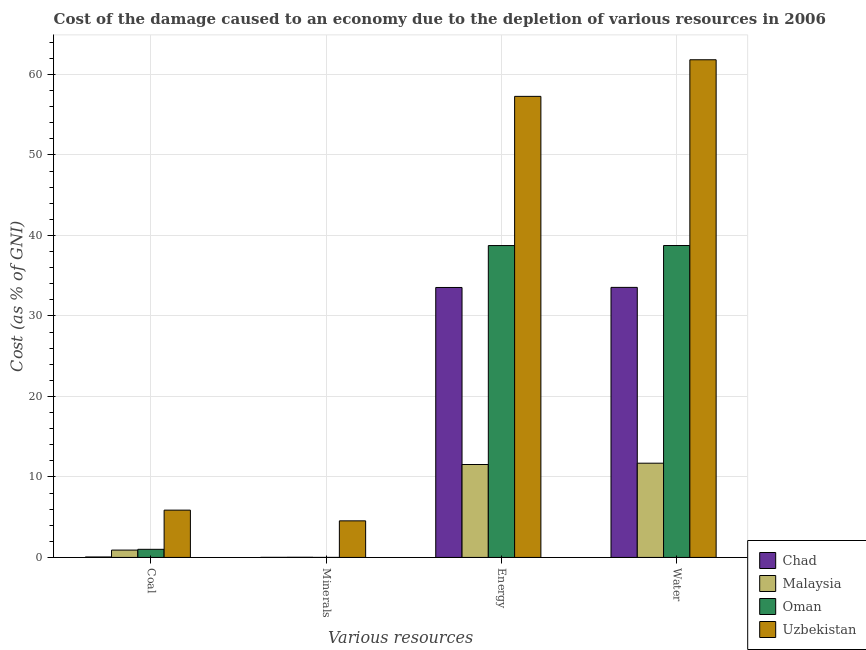Are the number of bars per tick equal to the number of legend labels?
Provide a succinct answer. Yes. Are the number of bars on each tick of the X-axis equal?
Ensure brevity in your answer.  Yes. How many bars are there on the 2nd tick from the left?
Your response must be concise. 4. How many bars are there on the 2nd tick from the right?
Offer a very short reply. 4. What is the label of the 4th group of bars from the left?
Make the answer very short. Water. What is the cost of damage due to depletion of energy in Chad?
Offer a terse response. 33.53. Across all countries, what is the maximum cost of damage due to depletion of energy?
Ensure brevity in your answer.  57.27. Across all countries, what is the minimum cost of damage due to depletion of minerals?
Your answer should be very brief. 0. In which country was the cost of damage due to depletion of coal maximum?
Offer a very short reply. Uzbekistan. In which country was the cost of damage due to depletion of water minimum?
Make the answer very short. Malaysia. What is the total cost of damage due to depletion of minerals in the graph?
Give a very brief answer. 4.58. What is the difference between the cost of damage due to depletion of minerals in Uzbekistan and that in Chad?
Your response must be concise. 4.53. What is the difference between the cost of damage due to depletion of coal in Uzbekistan and the cost of damage due to depletion of energy in Malaysia?
Keep it short and to the point. -5.67. What is the average cost of damage due to depletion of water per country?
Provide a succinct answer. 36.45. What is the difference between the cost of damage due to depletion of energy and cost of damage due to depletion of water in Malaysia?
Your response must be concise. -0.16. What is the ratio of the cost of damage due to depletion of minerals in Chad to that in Malaysia?
Offer a very short reply. 0.52. What is the difference between the highest and the second highest cost of damage due to depletion of minerals?
Your answer should be very brief. 4.52. What is the difference between the highest and the lowest cost of damage due to depletion of energy?
Ensure brevity in your answer.  45.73. In how many countries, is the cost of damage due to depletion of minerals greater than the average cost of damage due to depletion of minerals taken over all countries?
Give a very brief answer. 1. Is the sum of the cost of damage due to depletion of coal in Oman and Malaysia greater than the maximum cost of damage due to depletion of energy across all countries?
Ensure brevity in your answer.  No. What does the 1st bar from the left in Minerals represents?
Provide a short and direct response. Chad. What does the 2nd bar from the right in Coal represents?
Provide a short and direct response. Oman. Is it the case that in every country, the sum of the cost of damage due to depletion of coal and cost of damage due to depletion of minerals is greater than the cost of damage due to depletion of energy?
Give a very brief answer. No. How many bars are there?
Offer a very short reply. 16. Does the graph contain any zero values?
Make the answer very short. No. Where does the legend appear in the graph?
Make the answer very short. Bottom right. How are the legend labels stacked?
Ensure brevity in your answer.  Vertical. What is the title of the graph?
Your answer should be very brief. Cost of the damage caused to an economy due to the depletion of various resources in 2006 . Does "Latvia" appear as one of the legend labels in the graph?
Your answer should be very brief. No. What is the label or title of the X-axis?
Provide a short and direct response. Various resources. What is the label or title of the Y-axis?
Your answer should be compact. Cost (as % of GNI). What is the Cost (as % of GNI) of Chad in Coal?
Provide a succinct answer. 0.06. What is the Cost (as % of GNI) in Malaysia in Coal?
Your answer should be compact. 0.91. What is the Cost (as % of GNI) of Oman in Coal?
Your answer should be very brief. 1.01. What is the Cost (as % of GNI) of Uzbekistan in Coal?
Your response must be concise. 5.88. What is the Cost (as % of GNI) of Chad in Minerals?
Give a very brief answer. 0.01. What is the Cost (as % of GNI) of Malaysia in Minerals?
Your answer should be compact. 0.02. What is the Cost (as % of GNI) in Oman in Minerals?
Provide a succinct answer. 0. What is the Cost (as % of GNI) of Uzbekistan in Minerals?
Keep it short and to the point. 4.54. What is the Cost (as % of GNI) of Chad in Energy?
Your response must be concise. 33.53. What is the Cost (as % of GNI) of Malaysia in Energy?
Your answer should be very brief. 11.54. What is the Cost (as % of GNI) of Oman in Energy?
Give a very brief answer. 38.74. What is the Cost (as % of GNI) in Uzbekistan in Energy?
Offer a terse response. 57.27. What is the Cost (as % of GNI) of Chad in Water?
Give a very brief answer. 33.54. What is the Cost (as % of GNI) in Malaysia in Water?
Offer a very short reply. 11.71. What is the Cost (as % of GNI) in Oman in Water?
Your response must be concise. 38.75. What is the Cost (as % of GNI) of Uzbekistan in Water?
Give a very brief answer. 61.82. Across all Various resources, what is the maximum Cost (as % of GNI) in Chad?
Provide a short and direct response. 33.54. Across all Various resources, what is the maximum Cost (as % of GNI) of Malaysia?
Keep it short and to the point. 11.71. Across all Various resources, what is the maximum Cost (as % of GNI) in Oman?
Keep it short and to the point. 38.75. Across all Various resources, what is the maximum Cost (as % of GNI) of Uzbekistan?
Your answer should be compact. 61.82. Across all Various resources, what is the minimum Cost (as % of GNI) of Chad?
Make the answer very short. 0.01. Across all Various resources, what is the minimum Cost (as % of GNI) in Malaysia?
Your answer should be very brief. 0.02. Across all Various resources, what is the minimum Cost (as % of GNI) in Oman?
Keep it short and to the point. 0. Across all Various resources, what is the minimum Cost (as % of GNI) of Uzbekistan?
Your answer should be very brief. 4.54. What is the total Cost (as % of GNI) in Chad in the graph?
Provide a short and direct response. 67.15. What is the total Cost (as % of GNI) of Malaysia in the graph?
Offer a very short reply. 24.18. What is the total Cost (as % of GNI) of Oman in the graph?
Provide a succinct answer. 78.5. What is the total Cost (as % of GNI) in Uzbekistan in the graph?
Ensure brevity in your answer.  129.52. What is the difference between the Cost (as % of GNI) of Chad in Coal and that in Minerals?
Offer a terse response. 0.05. What is the difference between the Cost (as % of GNI) of Malaysia in Coal and that in Minerals?
Provide a succinct answer. 0.89. What is the difference between the Cost (as % of GNI) in Oman in Coal and that in Minerals?
Provide a short and direct response. 1. What is the difference between the Cost (as % of GNI) in Uzbekistan in Coal and that in Minerals?
Make the answer very short. 1.33. What is the difference between the Cost (as % of GNI) in Chad in Coal and that in Energy?
Offer a very short reply. -33.48. What is the difference between the Cost (as % of GNI) in Malaysia in Coal and that in Energy?
Provide a short and direct response. -10.63. What is the difference between the Cost (as % of GNI) of Oman in Coal and that in Energy?
Your answer should be compact. -37.73. What is the difference between the Cost (as % of GNI) in Uzbekistan in Coal and that in Energy?
Ensure brevity in your answer.  -51.4. What is the difference between the Cost (as % of GNI) of Chad in Coal and that in Water?
Offer a terse response. -33.49. What is the difference between the Cost (as % of GNI) of Malaysia in Coal and that in Water?
Make the answer very short. -10.79. What is the difference between the Cost (as % of GNI) of Oman in Coal and that in Water?
Your answer should be compact. -37.74. What is the difference between the Cost (as % of GNI) of Uzbekistan in Coal and that in Water?
Your response must be concise. -55.95. What is the difference between the Cost (as % of GNI) in Chad in Minerals and that in Energy?
Your response must be concise. -33.52. What is the difference between the Cost (as % of GNI) of Malaysia in Minerals and that in Energy?
Offer a very short reply. -11.52. What is the difference between the Cost (as % of GNI) of Oman in Minerals and that in Energy?
Offer a terse response. -38.74. What is the difference between the Cost (as % of GNI) in Uzbekistan in Minerals and that in Energy?
Your answer should be compact. -52.73. What is the difference between the Cost (as % of GNI) of Chad in Minerals and that in Water?
Provide a short and direct response. -33.53. What is the difference between the Cost (as % of GNI) of Malaysia in Minerals and that in Water?
Provide a short and direct response. -11.69. What is the difference between the Cost (as % of GNI) in Oman in Minerals and that in Water?
Your response must be concise. -38.74. What is the difference between the Cost (as % of GNI) in Uzbekistan in Minerals and that in Water?
Provide a succinct answer. -57.28. What is the difference between the Cost (as % of GNI) of Chad in Energy and that in Water?
Ensure brevity in your answer.  -0.01. What is the difference between the Cost (as % of GNI) in Malaysia in Energy and that in Water?
Your answer should be very brief. -0.16. What is the difference between the Cost (as % of GNI) in Oman in Energy and that in Water?
Keep it short and to the point. -0.01. What is the difference between the Cost (as % of GNI) in Uzbekistan in Energy and that in Water?
Offer a very short reply. -4.55. What is the difference between the Cost (as % of GNI) of Chad in Coal and the Cost (as % of GNI) of Malaysia in Minerals?
Provide a succinct answer. 0.04. What is the difference between the Cost (as % of GNI) in Chad in Coal and the Cost (as % of GNI) in Oman in Minerals?
Provide a succinct answer. 0.05. What is the difference between the Cost (as % of GNI) of Chad in Coal and the Cost (as % of GNI) of Uzbekistan in Minerals?
Provide a succinct answer. -4.49. What is the difference between the Cost (as % of GNI) in Malaysia in Coal and the Cost (as % of GNI) in Oman in Minerals?
Provide a succinct answer. 0.91. What is the difference between the Cost (as % of GNI) in Malaysia in Coal and the Cost (as % of GNI) in Uzbekistan in Minerals?
Your answer should be very brief. -3.63. What is the difference between the Cost (as % of GNI) of Oman in Coal and the Cost (as % of GNI) of Uzbekistan in Minerals?
Keep it short and to the point. -3.54. What is the difference between the Cost (as % of GNI) in Chad in Coal and the Cost (as % of GNI) in Malaysia in Energy?
Offer a terse response. -11.49. What is the difference between the Cost (as % of GNI) of Chad in Coal and the Cost (as % of GNI) of Oman in Energy?
Give a very brief answer. -38.69. What is the difference between the Cost (as % of GNI) in Chad in Coal and the Cost (as % of GNI) in Uzbekistan in Energy?
Your answer should be compact. -57.22. What is the difference between the Cost (as % of GNI) in Malaysia in Coal and the Cost (as % of GNI) in Oman in Energy?
Offer a very short reply. -37.83. What is the difference between the Cost (as % of GNI) of Malaysia in Coal and the Cost (as % of GNI) of Uzbekistan in Energy?
Make the answer very short. -56.36. What is the difference between the Cost (as % of GNI) of Oman in Coal and the Cost (as % of GNI) of Uzbekistan in Energy?
Offer a very short reply. -56.27. What is the difference between the Cost (as % of GNI) in Chad in Coal and the Cost (as % of GNI) in Malaysia in Water?
Ensure brevity in your answer.  -11.65. What is the difference between the Cost (as % of GNI) of Chad in Coal and the Cost (as % of GNI) of Oman in Water?
Offer a terse response. -38.69. What is the difference between the Cost (as % of GNI) of Chad in Coal and the Cost (as % of GNI) of Uzbekistan in Water?
Give a very brief answer. -61.77. What is the difference between the Cost (as % of GNI) in Malaysia in Coal and the Cost (as % of GNI) in Oman in Water?
Keep it short and to the point. -37.83. What is the difference between the Cost (as % of GNI) of Malaysia in Coal and the Cost (as % of GNI) of Uzbekistan in Water?
Provide a succinct answer. -60.91. What is the difference between the Cost (as % of GNI) of Oman in Coal and the Cost (as % of GNI) of Uzbekistan in Water?
Your answer should be very brief. -60.82. What is the difference between the Cost (as % of GNI) of Chad in Minerals and the Cost (as % of GNI) of Malaysia in Energy?
Give a very brief answer. -11.53. What is the difference between the Cost (as % of GNI) of Chad in Minerals and the Cost (as % of GNI) of Oman in Energy?
Your response must be concise. -38.73. What is the difference between the Cost (as % of GNI) in Chad in Minerals and the Cost (as % of GNI) in Uzbekistan in Energy?
Give a very brief answer. -57.26. What is the difference between the Cost (as % of GNI) in Malaysia in Minerals and the Cost (as % of GNI) in Oman in Energy?
Offer a very short reply. -38.72. What is the difference between the Cost (as % of GNI) of Malaysia in Minerals and the Cost (as % of GNI) of Uzbekistan in Energy?
Provide a short and direct response. -57.25. What is the difference between the Cost (as % of GNI) in Oman in Minerals and the Cost (as % of GNI) in Uzbekistan in Energy?
Your response must be concise. -57.27. What is the difference between the Cost (as % of GNI) of Chad in Minerals and the Cost (as % of GNI) of Malaysia in Water?
Make the answer very short. -11.7. What is the difference between the Cost (as % of GNI) of Chad in Minerals and the Cost (as % of GNI) of Oman in Water?
Your response must be concise. -38.74. What is the difference between the Cost (as % of GNI) of Chad in Minerals and the Cost (as % of GNI) of Uzbekistan in Water?
Provide a short and direct response. -61.81. What is the difference between the Cost (as % of GNI) of Malaysia in Minerals and the Cost (as % of GNI) of Oman in Water?
Provide a succinct answer. -38.73. What is the difference between the Cost (as % of GNI) of Malaysia in Minerals and the Cost (as % of GNI) of Uzbekistan in Water?
Your answer should be very brief. -61.8. What is the difference between the Cost (as % of GNI) in Oman in Minerals and the Cost (as % of GNI) in Uzbekistan in Water?
Make the answer very short. -61.82. What is the difference between the Cost (as % of GNI) of Chad in Energy and the Cost (as % of GNI) of Malaysia in Water?
Offer a very short reply. 21.83. What is the difference between the Cost (as % of GNI) in Chad in Energy and the Cost (as % of GNI) in Oman in Water?
Provide a succinct answer. -5.21. What is the difference between the Cost (as % of GNI) in Chad in Energy and the Cost (as % of GNI) in Uzbekistan in Water?
Your answer should be compact. -28.29. What is the difference between the Cost (as % of GNI) of Malaysia in Energy and the Cost (as % of GNI) of Oman in Water?
Keep it short and to the point. -27.2. What is the difference between the Cost (as % of GNI) in Malaysia in Energy and the Cost (as % of GNI) in Uzbekistan in Water?
Offer a terse response. -50.28. What is the difference between the Cost (as % of GNI) in Oman in Energy and the Cost (as % of GNI) in Uzbekistan in Water?
Offer a terse response. -23.08. What is the average Cost (as % of GNI) of Chad per Various resources?
Offer a very short reply. 16.79. What is the average Cost (as % of GNI) of Malaysia per Various resources?
Make the answer very short. 6.05. What is the average Cost (as % of GNI) of Oman per Various resources?
Provide a succinct answer. 19.62. What is the average Cost (as % of GNI) in Uzbekistan per Various resources?
Your answer should be very brief. 32.38. What is the difference between the Cost (as % of GNI) in Chad and Cost (as % of GNI) in Malaysia in Coal?
Your answer should be compact. -0.86. What is the difference between the Cost (as % of GNI) of Chad and Cost (as % of GNI) of Oman in Coal?
Offer a very short reply. -0.95. What is the difference between the Cost (as % of GNI) in Chad and Cost (as % of GNI) in Uzbekistan in Coal?
Keep it short and to the point. -5.82. What is the difference between the Cost (as % of GNI) of Malaysia and Cost (as % of GNI) of Oman in Coal?
Offer a terse response. -0.09. What is the difference between the Cost (as % of GNI) in Malaysia and Cost (as % of GNI) in Uzbekistan in Coal?
Ensure brevity in your answer.  -4.96. What is the difference between the Cost (as % of GNI) of Oman and Cost (as % of GNI) of Uzbekistan in Coal?
Provide a short and direct response. -4.87. What is the difference between the Cost (as % of GNI) of Chad and Cost (as % of GNI) of Malaysia in Minerals?
Make the answer very short. -0.01. What is the difference between the Cost (as % of GNI) in Chad and Cost (as % of GNI) in Oman in Minerals?
Provide a succinct answer. 0.01. What is the difference between the Cost (as % of GNI) of Chad and Cost (as % of GNI) of Uzbekistan in Minerals?
Offer a terse response. -4.53. What is the difference between the Cost (as % of GNI) of Malaysia and Cost (as % of GNI) of Oman in Minerals?
Provide a succinct answer. 0.02. What is the difference between the Cost (as % of GNI) in Malaysia and Cost (as % of GNI) in Uzbekistan in Minerals?
Provide a succinct answer. -4.52. What is the difference between the Cost (as % of GNI) in Oman and Cost (as % of GNI) in Uzbekistan in Minerals?
Give a very brief answer. -4.54. What is the difference between the Cost (as % of GNI) of Chad and Cost (as % of GNI) of Malaysia in Energy?
Your answer should be compact. 21.99. What is the difference between the Cost (as % of GNI) in Chad and Cost (as % of GNI) in Oman in Energy?
Your response must be concise. -5.21. What is the difference between the Cost (as % of GNI) in Chad and Cost (as % of GNI) in Uzbekistan in Energy?
Your response must be concise. -23.74. What is the difference between the Cost (as % of GNI) in Malaysia and Cost (as % of GNI) in Oman in Energy?
Provide a succinct answer. -27.2. What is the difference between the Cost (as % of GNI) in Malaysia and Cost (as % of GNI) in Uzbekistan in Energy?
Offer a terse response. -45.73. What is the difference between the Cost (as % of GNI) of Oman and Cost (as % of GNI) of Uzbekistan in Energy?
Provide a short and direct response. -18.53. What is the difference between the Cost (as % of GNI) of Chad and Cost (as % of GNI) of Malaysia in Water?
Give a very brief answer. 21.84. What is the difference between the Cost (as % of GNI) in Chad and Cost (as % of GNI) in Oman in Water?
Give a very brief answer. -5.2. What is the difference between the Cost (as % of GNI) in Chad and Cost (as % of GNI) in Uzbekistan in Water?
Provide a short and direct response. -28.28. What is the difference between the Cost (as % of GNI) in Malaysia and Cost (as % of GNI) in Oman in Water?
Your answer should be very brief. -27.04. What is the difference between the Cost (as % of GNI) of Malaysia and Cost (as % of GNI) of Uzbekistan in Water?
Make the answer very short. -50.12. What is the difference between the Cost (as % of GNI) of Oman and Cost (as % of GNI) of Uzbekistan in Water?
Provide a short and direct response. -23.08. What is the ratio of the Cost (as % of GNI) in Chad in Coal to that in Minerals?
Make the answer very short. 5.44. What is the ratio of the Cost (as % of GNI) of Malaysia in Coal to that in Minerals?
Your answer should be compact. 46.86. What is the ratio of the Cost (as % of GNI) in Oman in Coal to that in Minerals?
Give a very brief answer. 427.23. What is the ratio of the Cost (as % of GNI) in Uzbekistan in Coal to that in Minerals?
Keep it short and to the point. 1.29. What is the ratio of the Cost (as % of GNI) of Chad in Coal to that in Energy?
Offer a terse response. 0. What is the ratio of the Cost (as % of GNI) in Malaysia in Coal to that in Energy?
Your answer should be compact. 0.08. What is the ratio of the Cost (as % of GNI) in Oman in Coal to that in Energy?
Offer a terse response. 0.03. What is the ratio of the Cost (as % of GNI) of Uzbekistan in Coal to that in Energy?
Keep it short and to the point. 0.1. What is the ratio of the Cost (as % of GNI) of Chad in Coal to that in Water?
Your answer should be very brief. 0. What is the ratio of the Cost (as % of GNI) in Malaysia in Coal to that in Water?
Offer a terse response. 0.08. What is the ratio of the Cost (as % of GNI) in Oman in Coal to that in Water?
Ensure brevity in your answer.  0.03. What is the ratio of the Cost (as % of GNI) of Uzbekistan in Coal to that in Water?
Ensure brevity in your answer.  0.1. What is the ratio of the Cost (as % of GNI) of Malaysia in Minerals to that in Energy?
Give a very brief answer. 0. What is the ratio of the Cost (as % of GNI) in Uzbekistan in Minerals to that in Energy?
Offer a very short reply. 0.08. What is the ratio of the Cost (as % of GNI) in Malaysia in Minerals to that in Water?
Give a very brief answer. 0. What is the ratio of the Cost (as % of GNI) of Uzbekistan in Minerals to that in Water?
Offer a terse response. 0.07. What is the ratio of the Cost (as % of GNI) in Chad in Energy to that in Water?
Offer a very short reply. 1. What is the ratio of the Cost (as % of GNI) of Malaysia in Energy to that in Water?
Offer a terse response. 0.99. What is the ratio of the Cost (as % of GNI) of Oman in Energy to that in Water?
Offer a very short reply. 1. What is the ratio of the Cost (as % of GNI) of Uzbekistan in Energy to that in Water?
Offer a very short reply. 0.93. What is the difference between the highest and the second highest Cost (as % of GNI) of Chad?
Your answer should be compact. 0.01. What is the difference between the highest and the second highest Cost (as % of GNI) in Malaysia?
Make the answer very short. 0.16. What is the difference between the highest and the second highest Cost (as % of GNI) of Oman?
Provide a succinct answer. 0.01. What is the difference between the highest and the second highest Cost (as % of GNI) in Uzbekistan?
Offer a very short reply. 4.55. What is the difference between the highest and the lowest Cost (as % of GNI) of Chad?
Your answer should be compact. 33.53. What is the difference between the highest and the lowest Cost (as % of GNI) in Malaysia?
Make the answer very short. 11.69. What is the difference between the highest and the lowest Cost (as % of GNI) in Oman?
Provide a succinct answer. 38.74. What is the difference between the highest and the lowest Cost (as % of GNI) of Uzbekistan?
Your answer should be very brief. 57.28. 